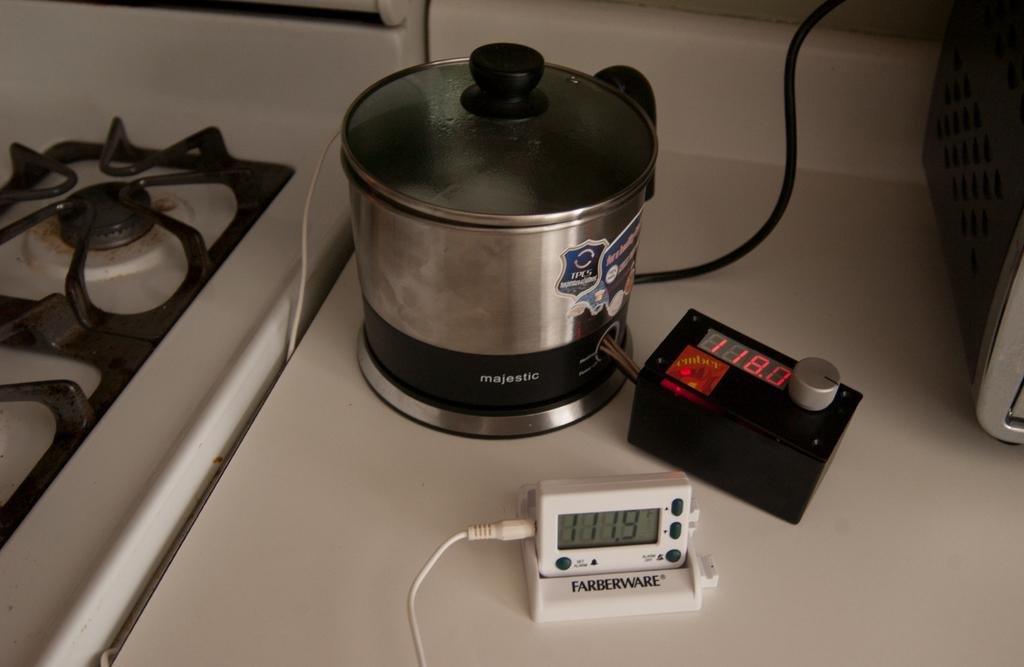<image>
Give a short and clear explanation of the subsequent image. A Farberware kitchen timer sits on a counter next to a pot and another timer. 